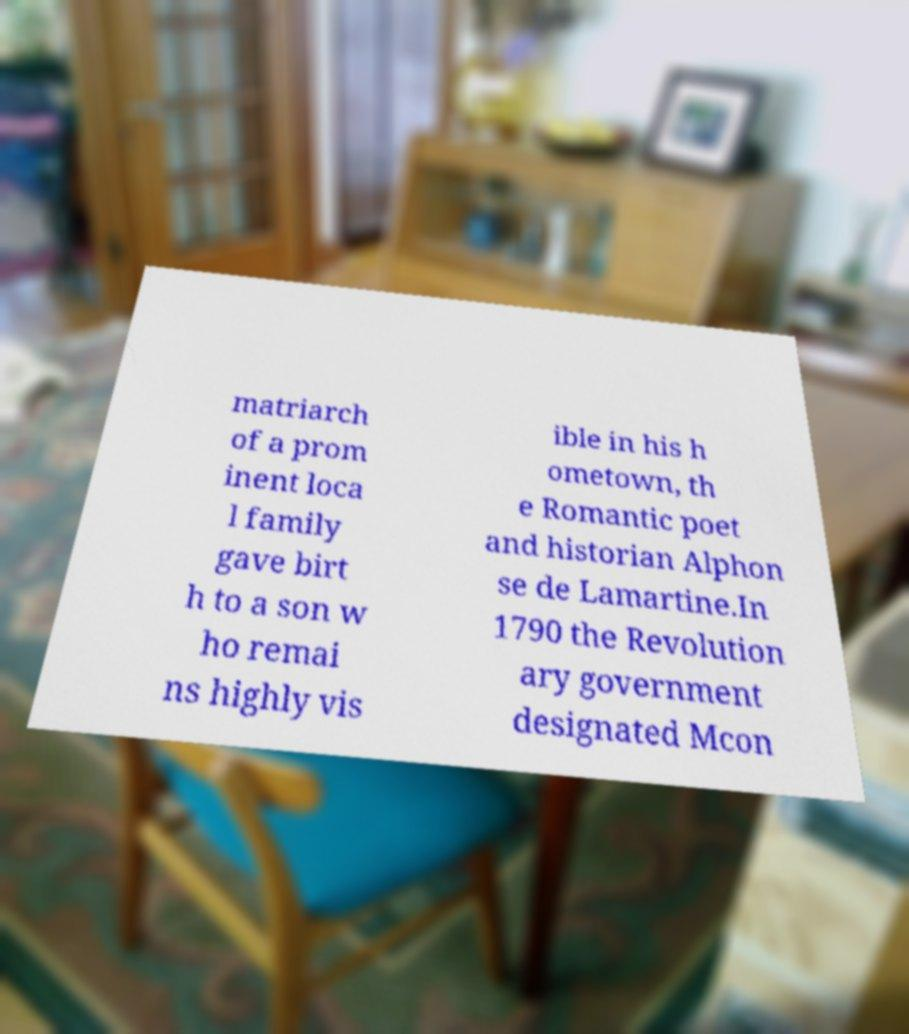Could you extract and type out the text from this image? matriarch of a prom inent loca l family gave birt h to a son w ho remai ns highly vis ible in his h ometown, th e Romantic poet and historian Alphon se de Lamartine.In 1790 the Revolution ary government designated Mcon 